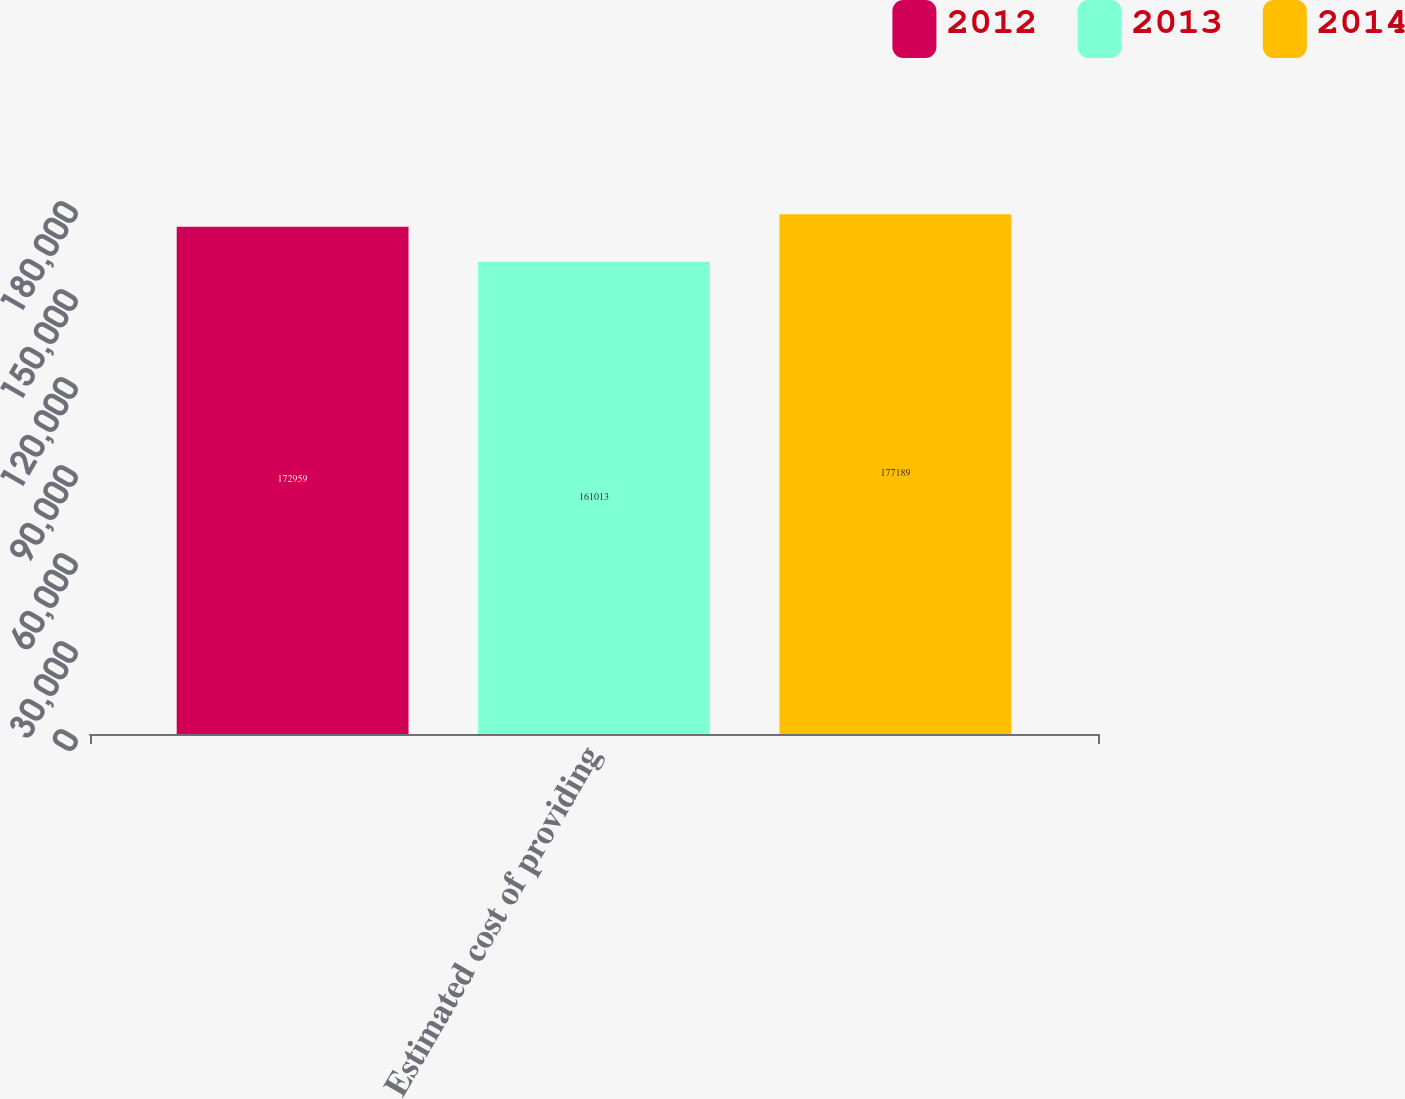Convert chart to OTSL. <chart><loc_0><loc_0><loc_500><loc_500><stacked_bar_chart><ecel><fcel>Estimated cost of providing<nl><fcel>2012<fcel>172959<nl><fcel>2013<fcel>161013<nl><fcel>2014<fcel>177189<nl></chart> 